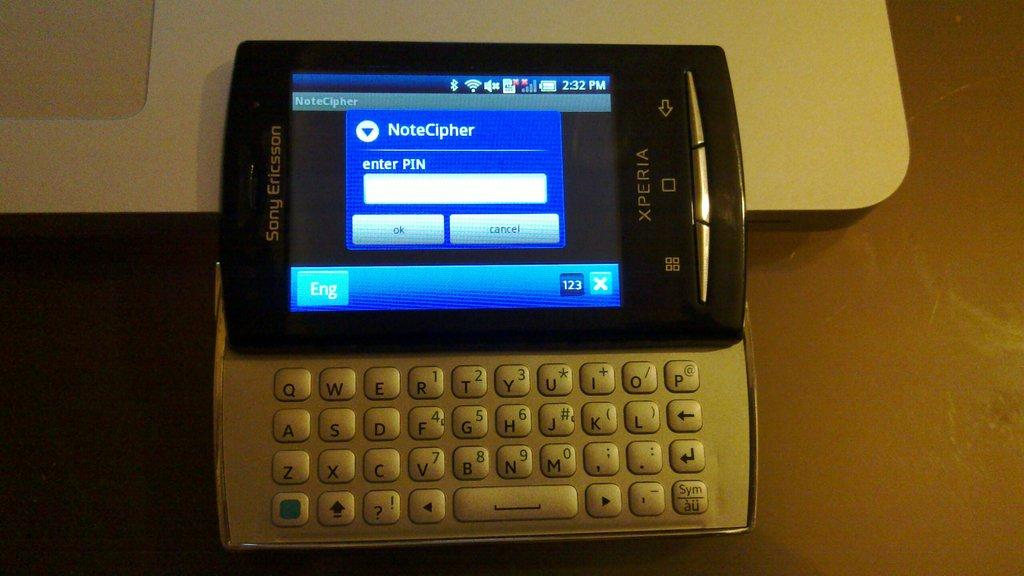<image>
Summarize the visual content of the image. A computer with NoteCipher and a pin on it. 